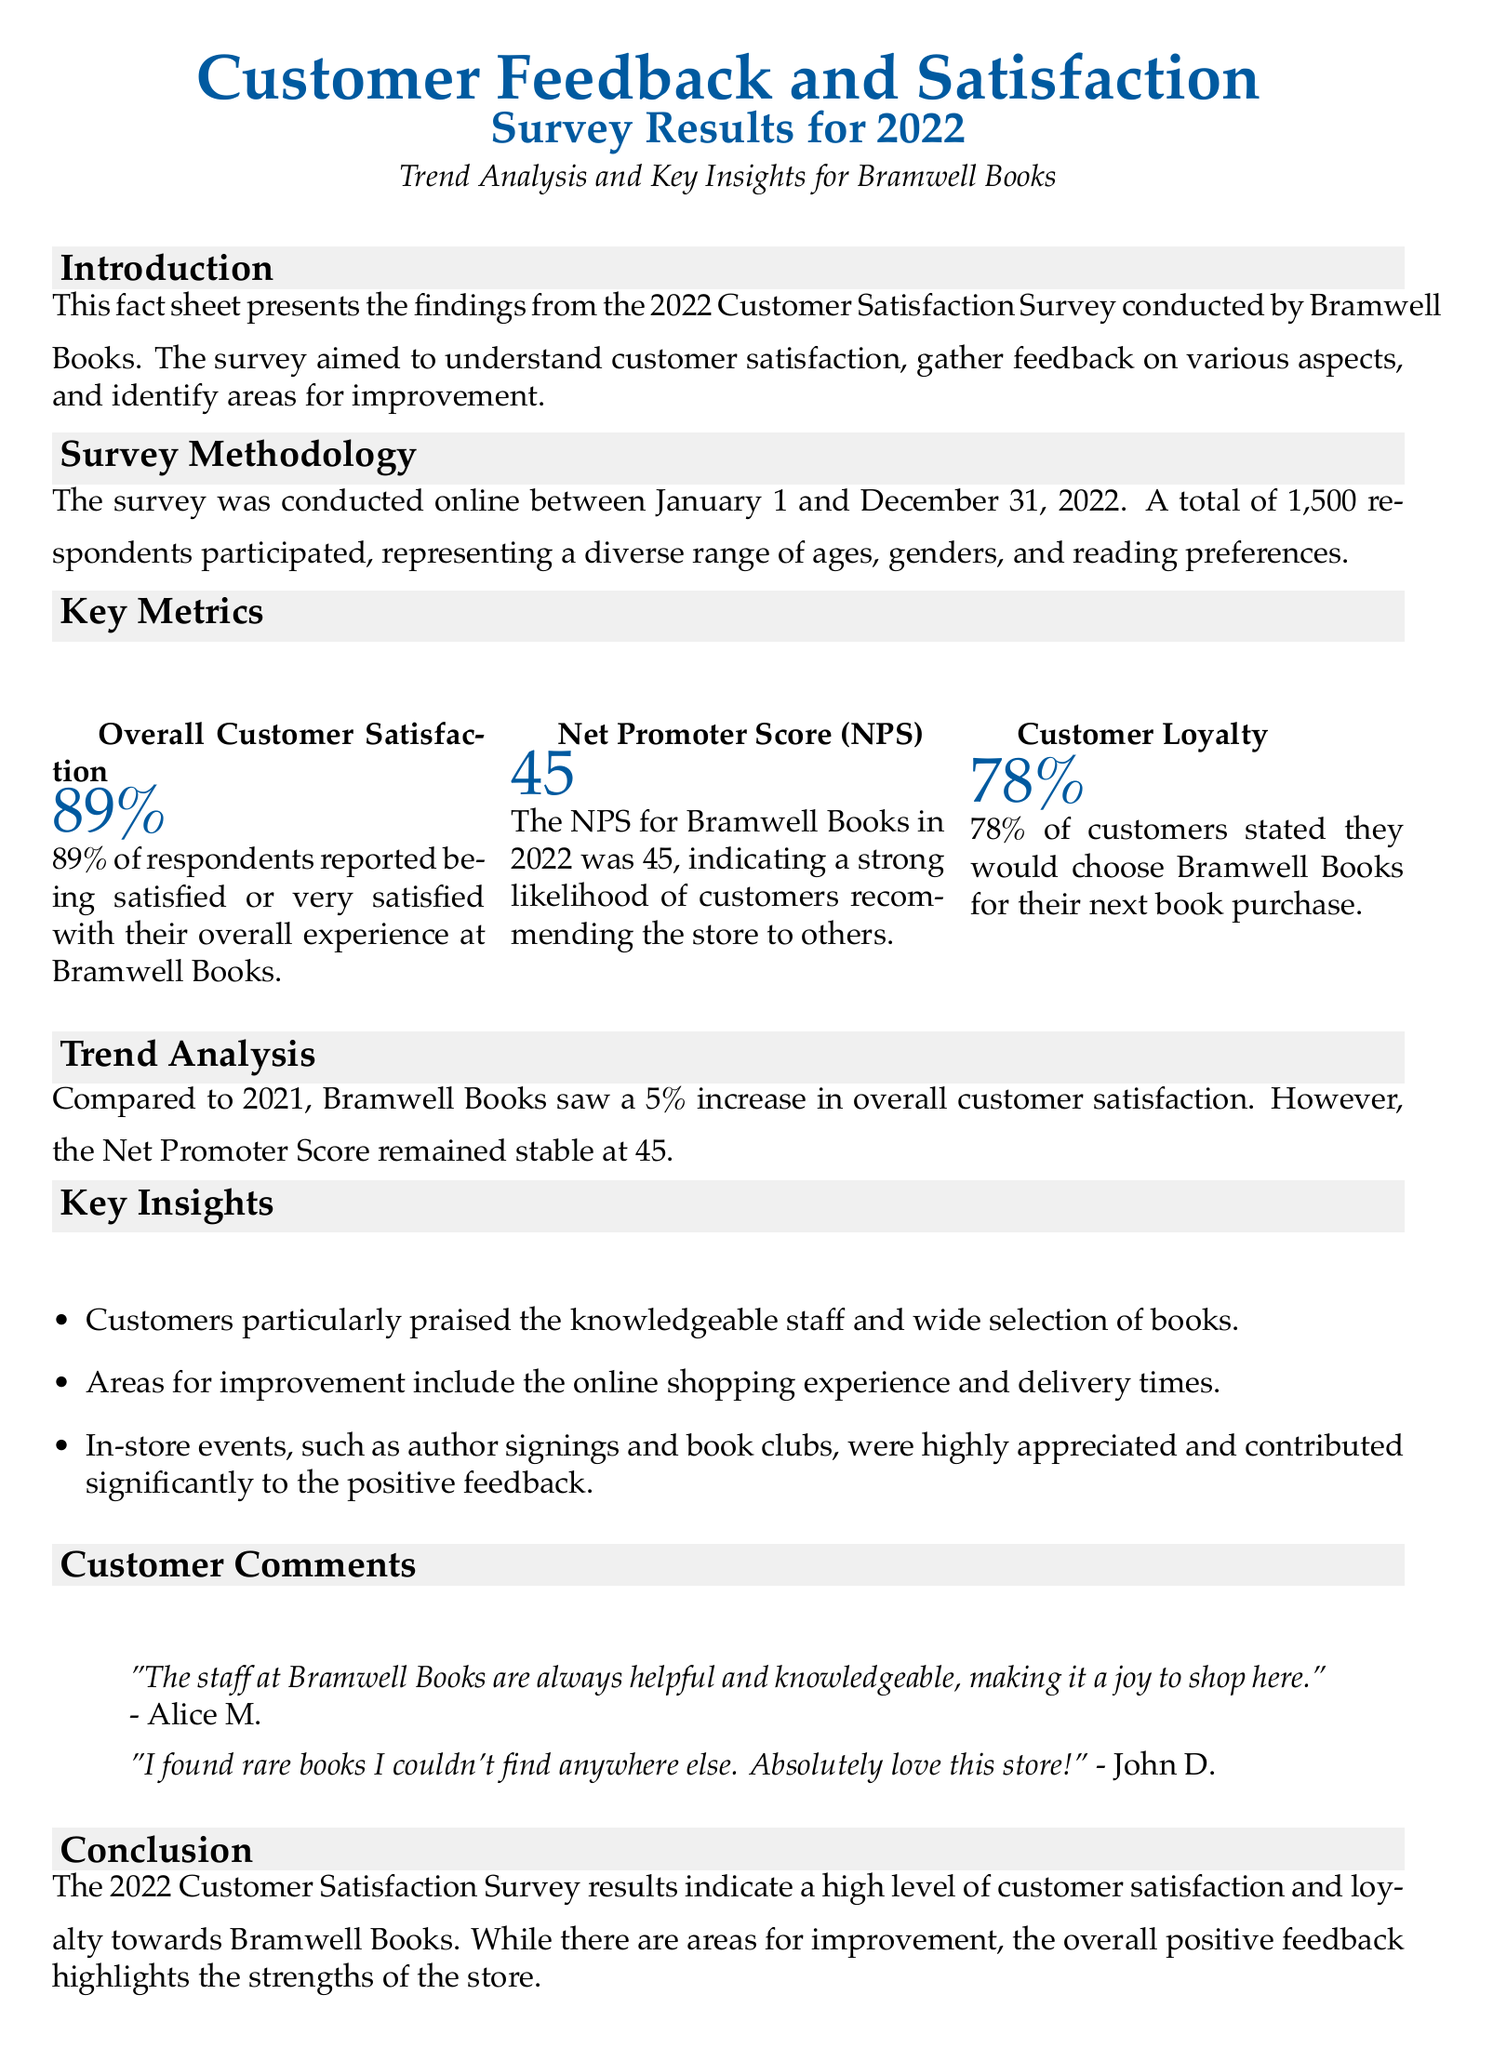What was the overall customer satisfaction percentage? The overall customer satisfaction percentage is stated in the document as 89%.
Answer: 89% What is the Net Promoter Score (NPS) for Bramwell Books in 2022? The NPS is a key metric provided in the document reflecting the likelihood of recommendations, which is 45.
Answer: 45 What percentage of customers stated they would choose Bramwell Books for their next purchase? The document includes this loyalty metric, indicating that 78% of customers would choose Bramwell Books.
Answer: 78% What improvement area is highlighted regarding the shopping experience? The document mentions that the online shopping experience needs improvement.
Answer: Online shopping experience How much did overall customer satisfaction increase compared to 2021? The document provides a comparison, stating there was a 5% increase in overall customer satisfaction.
Answer: 5% Which aspect of customer experience received praise according to the comments? The document includes customer feedback highlighting knowledgeable staff as a praised aspect.
Answer: Knowledgeable staff What event types were appreciated by customers according to the insights? The insights suggest that in-store events such as author signings and book clubs were positively received.
Answer: In-store events When was the survey conducted? The document specifies that the survey took place between January 1 and December 31, 2022.
Answer: January 1 to December 31, 2022 What demographic represented the survey respondents? The document notes that the respondents represented a diverse range of ages, genders, and reading preferences.
Answer: Diverse range of ages, genders, and reading preferences 